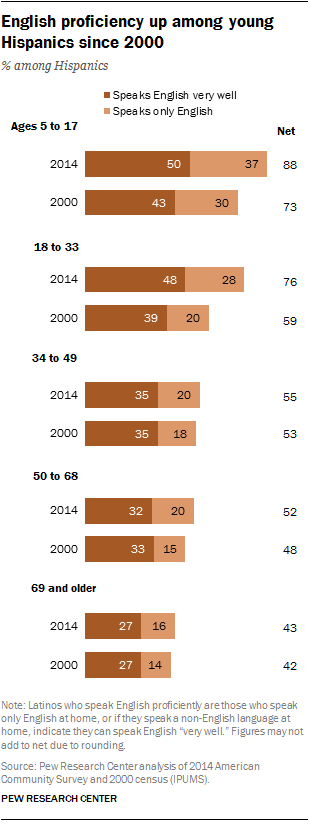Highlight a few significant elements in this photo. According to data from 2014, the number of young Hispanics who speak English very well for the age range of 5 to 17 is estimated to be approximately 50. The number of young Hispanics that spoke English very well between the ages of 5 and 17 in 2014 was different from the number of young Hispanics that spoke English very well between the ages of 18 and 33 in 2014. 